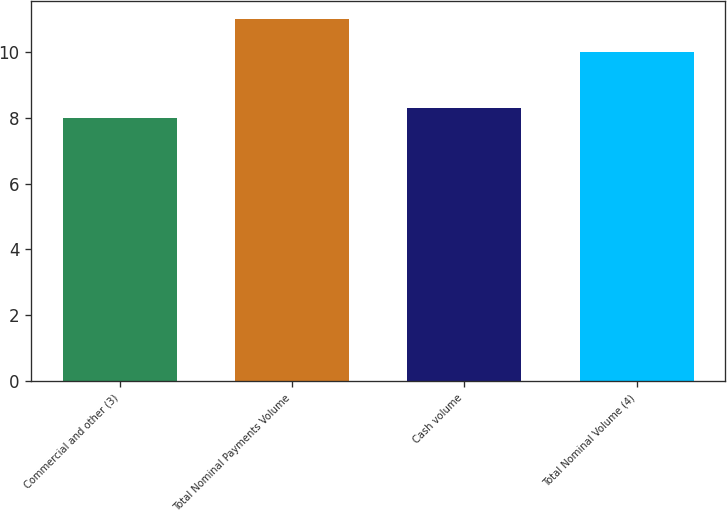<chart> <loc_0><loc_0><loc_500><loc_500><bar_chart><fcel>Commercial and other (3)<fcel>Total Nominal Payments Volume<fcel>Cash volume<fcel>Total Nominal Volume (4)<nl><fcel>8<fcel>11<fcel>8.3<fcel>10<nl></chart> 